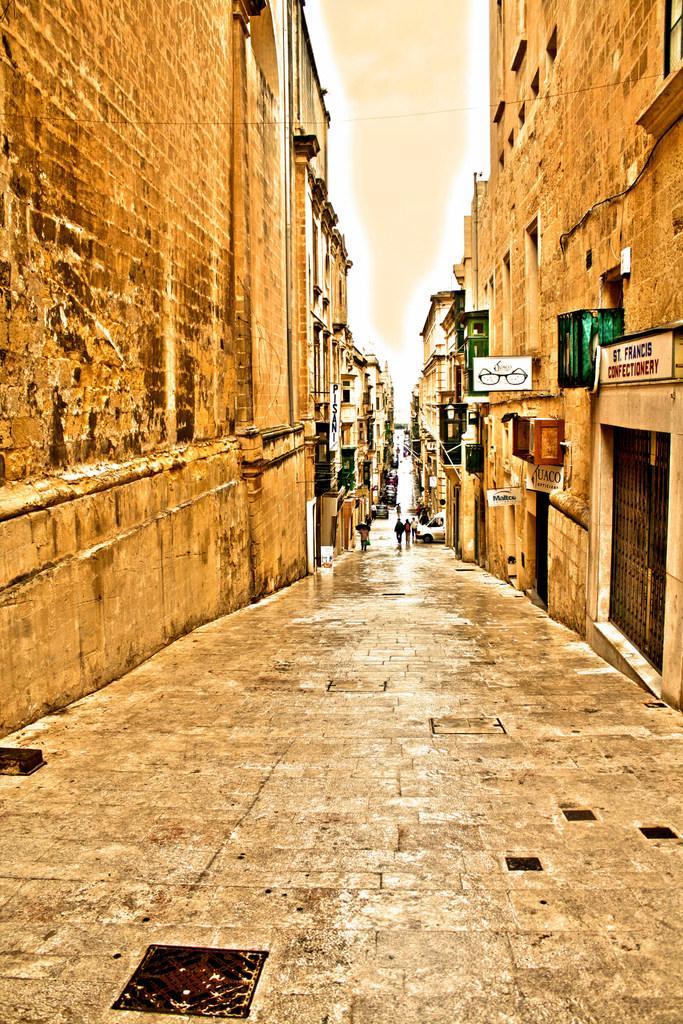Can you describe this image briefly? In this image we can see street in which there are some group of persons walking, there are some vehicles moving, there are some buildings on left and Right side of the image. 